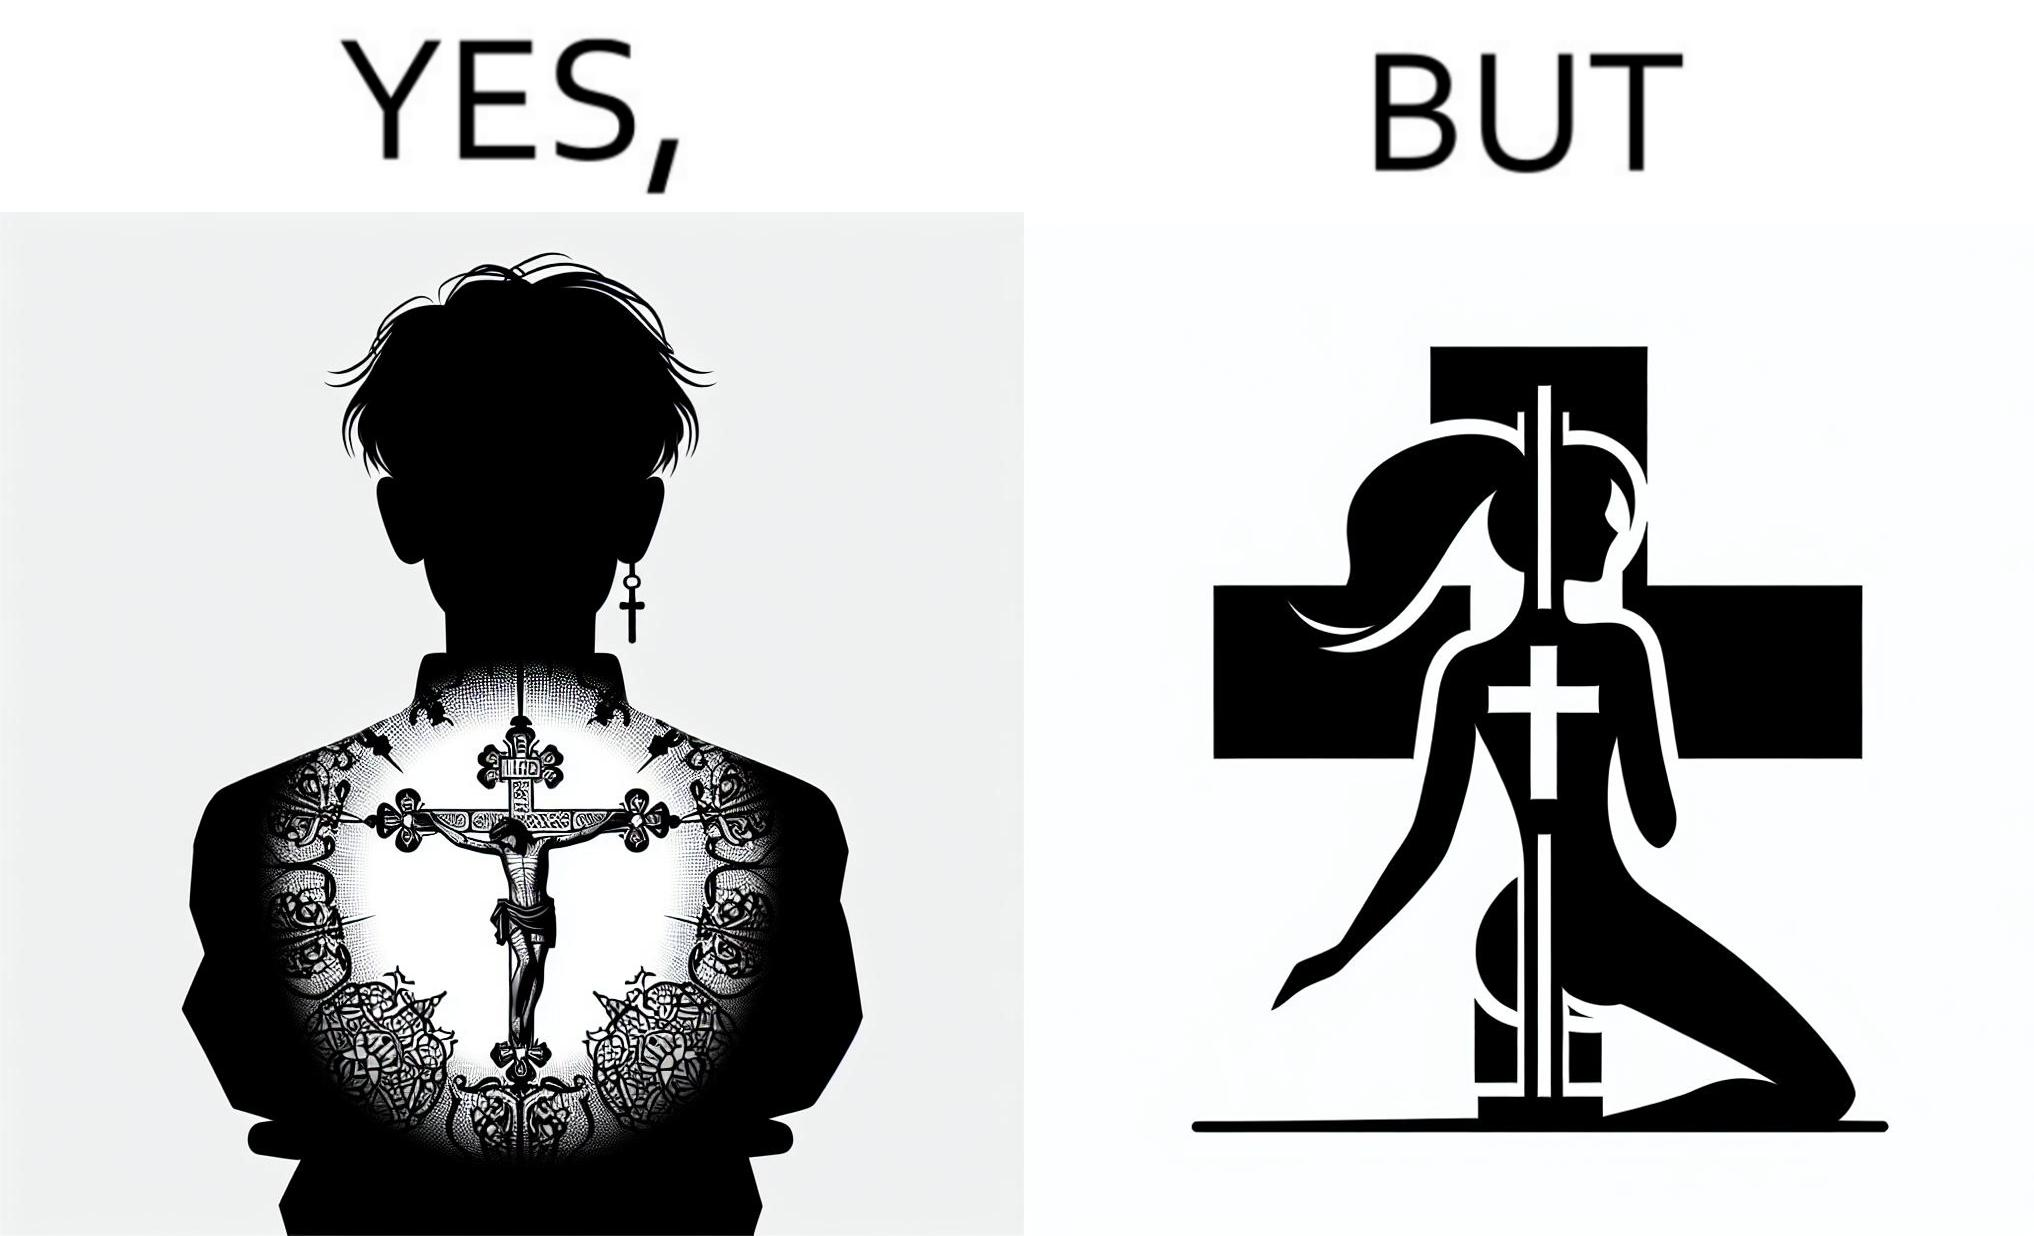Compare the left and right sides of this image. In the left part of the image: a tatto of holy cross symbol on the back of a girl,maybe she follows christianity as her religion In the right part of the image: a pole dancer performing, having a tatto of holy cross symbol on her back 